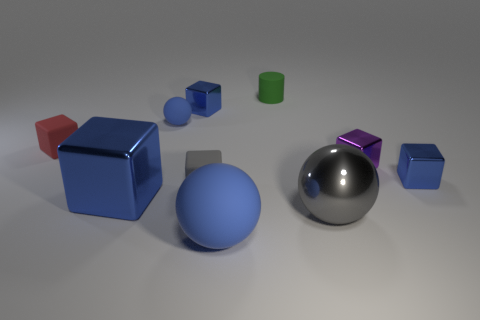There is a gray object behind the large gray shiny sphere; how big is it?
Your answer should be very brief. Small. Are there fewer large brown cylinders than tiny blue matte balls?
Make the answer very short. Yes. Are there any other matte spheres of the same color as the large rubber sphere?
Ensure brevity in your answer.  Yes. What shape is the small rubber object that is both on the right side of the small red object and to the left of the gray cube?
Keep it short and to the point. Sphere. The large rubber thing in front of the blue cube right of the gray matte cube is what shape?
Offer a terse response. Sphere. Do the purple metallic object and the tiny red matte object have the same shape?
Your answer should be compact. Yes. There is another sphere that is the same color as the tiny matte sphere; what is its material?
Offer a terse response. Rubber. Do the big matte ball and the large metallic block have the same color?
Keep it short and to the point. Yes. How many purple shiny objects are behind the big shiny object that is on the right side of the large metal object behind the gray sphere?
Provide a short and direct response. 1. The big blue thing that is the same material as the purple block is what shape?
Your answer should be very brief. Cube. 